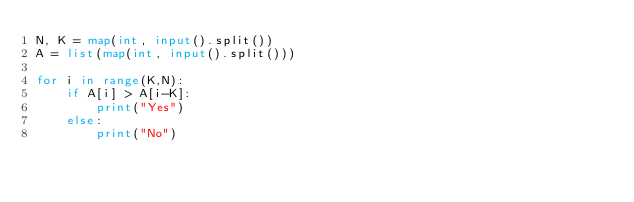<code> <loc_0><loc_0><loc_500><loc_500><_Python_>N, K = map(int, input().split())
A = list(map(int, input().split()))

for i in range(K,N):
    if A[i] > A[i-K]:
        print("Yes")
    else:
        print("No")</code> 